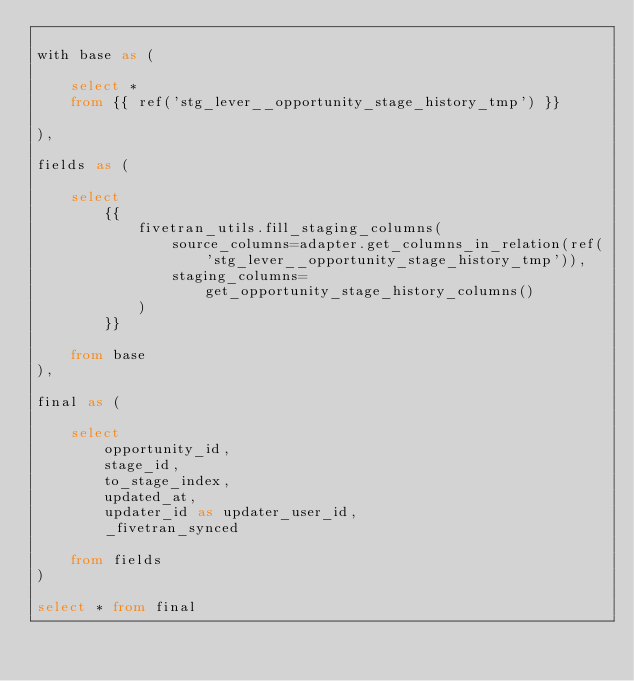<code> <loc_0><loc_0><loc_500><loc_500><_SQL_>
with base as (

    select * 
    from {{ ref('stg_lever__opportunity_stage_history_tmp') }}

),

fields as (

    select
        {{
            fivetran_utils.fill_staging_columns(
                source_columns=adapter.get_columns_in_relation(ref('stg_lever__opportunity_stage_history_tmp')),
                staging_columns=get_opportunity_stage_history_columns()
            )
        }}
        
    from base
),

final as (
    
    select 
        opportunity_id,
        stage_id,
        to_stage_index,
        updated_at,
        updater_id as updater_user_id,
        _fivetran_synced

    from fields
)

select * from final
</code> 